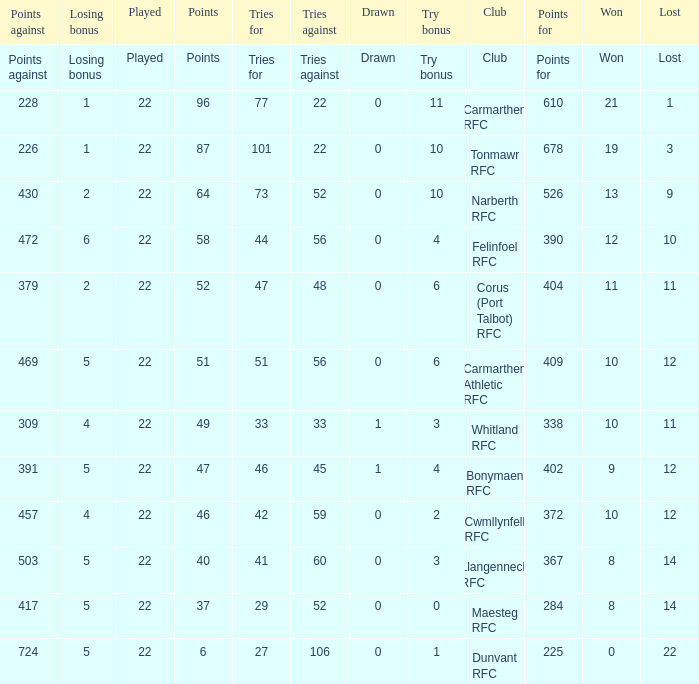Name the points against for 51 points 469.0. 